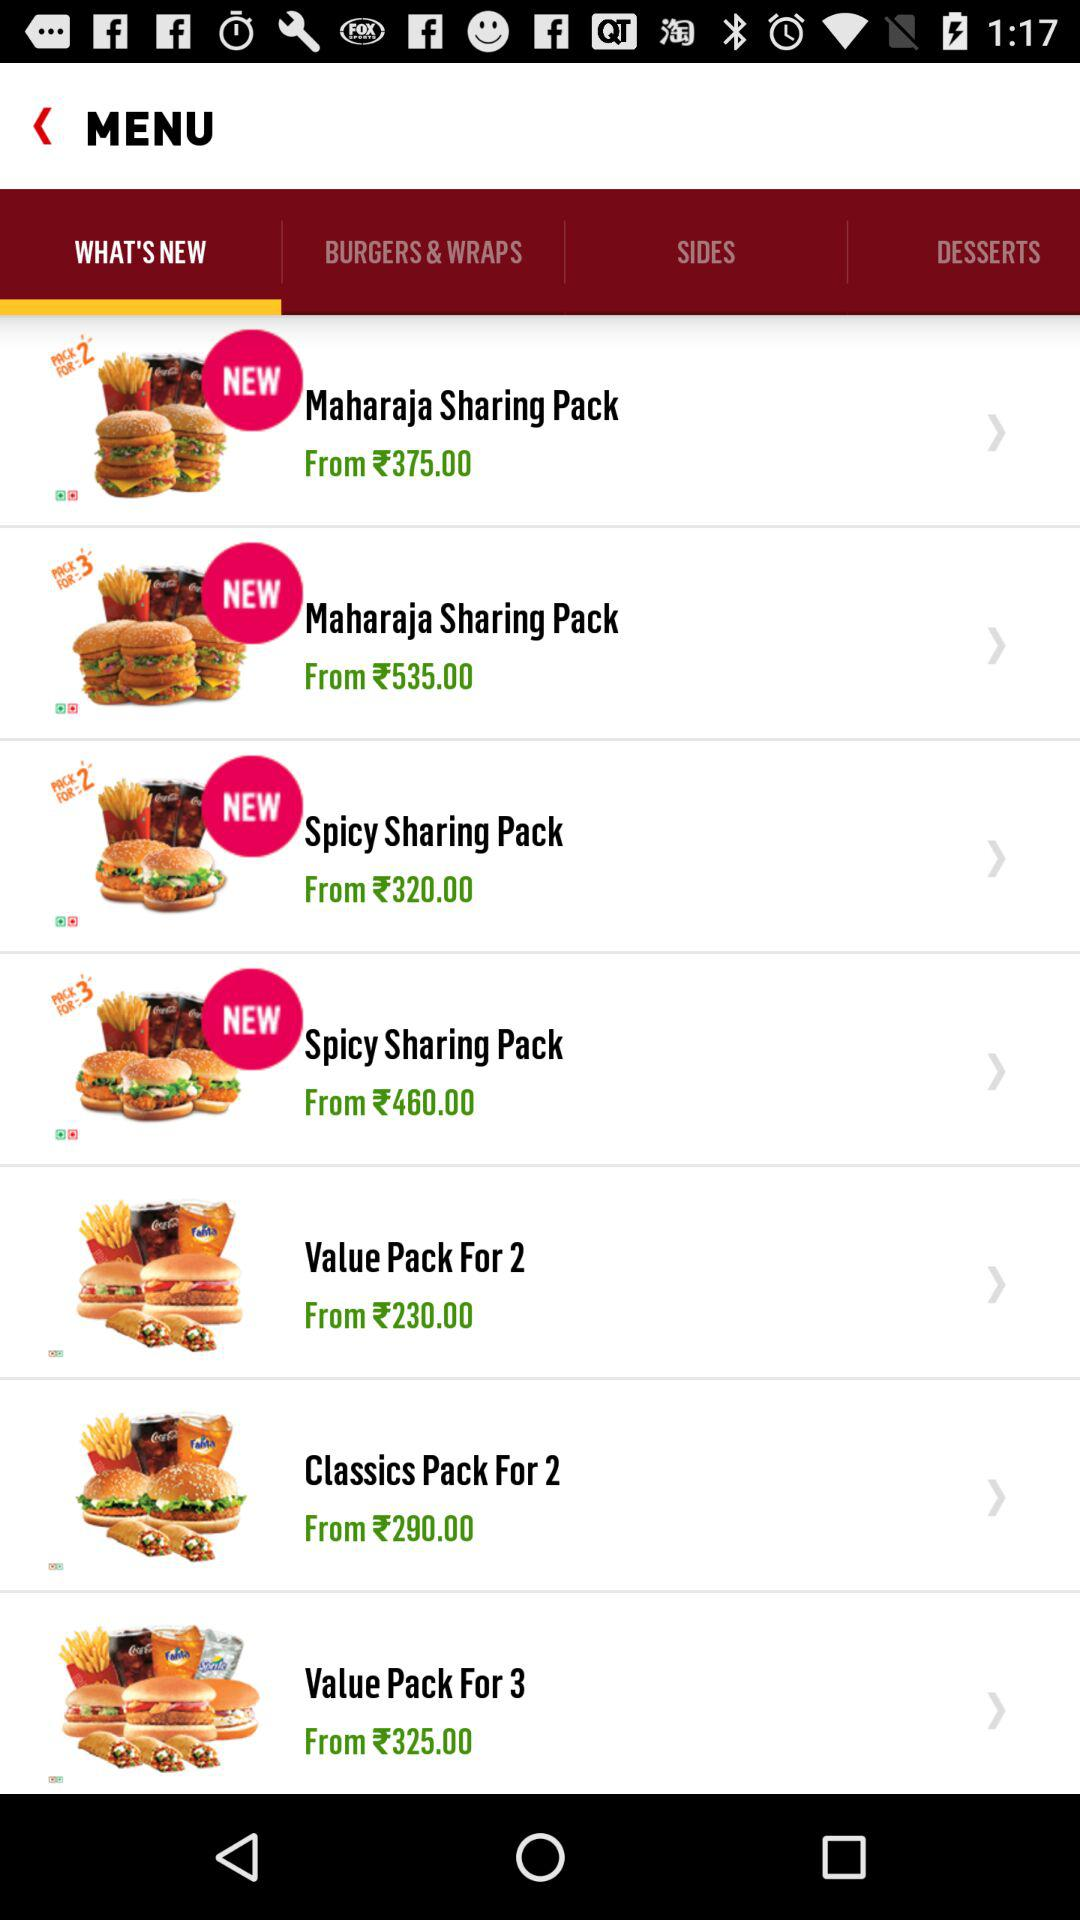Which tab is selected? The selected tab is "WHAT'S NEW". 